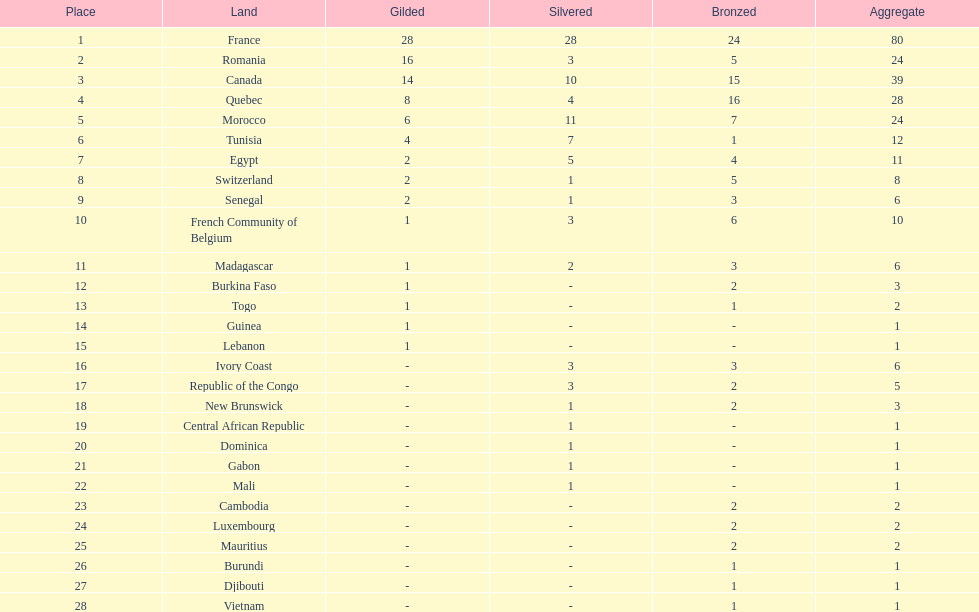How many bronze medals does togo have? 1. 